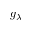Convert formula to latex. <formula><loc_0><loc_0><loc_500><loc_500>g _ { \lambda }</formula> 